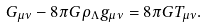<formula> <loc_0><loc_0><loc_500><loc_500>G _ { \mu \nu } - 8 \pi G \rho _ { \Lambda } g _ { \mu \nu } = 8 \pi G T _ { \mu \nu } .</formula> 